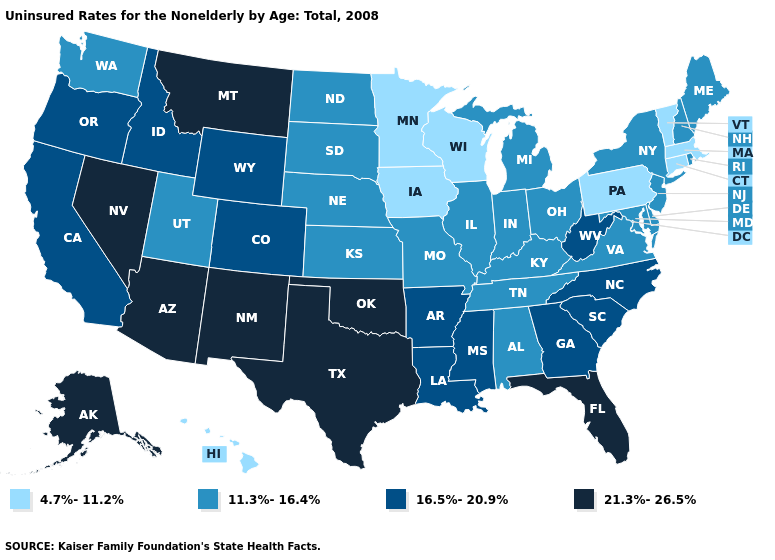Which states hav the highest value in the Northeast?
Short answer required. Maine, New Hampshire, New Jersey, New York, Rhode Island. Among the states that border Kentucky , which have the highest value?
Short answer required. West Virginia. What is the highest value in the USA?
Short answer required. 21.3%-26.5%. Does Wisconsin have a higher value than Kansas?
Answer briefly. No. What is the lowest value in the USA?
Write a very short answer. 4.7%-11.2%. What is the value of New Mexico?
Answer briefly. 21.3%-26.5%. What is the value of Maryland?
Be succinct. 11.3%-16.4%. Name the states that have a value in the range 4.7%-11.2%?
Concise answer only. Connecticut, Hawaii, Iowa, Massachusetts, Minnesota, Pennsylvania, Vermont, Wisconsin. Name the states that have a value in the range 11.3%-16.4%?
Write a very short answer. Alabama, Delaware, Illinois, Indiana, Kansas, Kentucky, Maine, Maryland, Michigan, Missouri, Nebraska, New Hampshire, New Jersey, New York, North Dakota, Ohio, Rhode Island, South Dakota, Tennessee, Utah, Virginia, Washington. What is the lowest value in the Northeast?
Answer briefly. 4.7%-11.2%. Name the states that have a value in the range 11.3%-16.4%?
Write a very short answer. Alabama, Delaware, Illinois, Indiana, Kansas, Kentucky, Maine, Maryland, Michigan, Missouri, Nebraska, New Hampshire, New Jersey, New York, North Dakota, Ohio, Rhode Island, South Dakota, Tennessee, Utah, Virginia, Washington. Does Georgia have the highest value in the South?
Be succinct. No. Does the map have missing data?
Be succinct. No. Which states hav the highest value in the Northeast?
Keep it brief. Maine, New Hampshire, New Jersey, New York, Rhode Island. Does New York have the lowest value in the Northeast?
Keep it brief. No. 